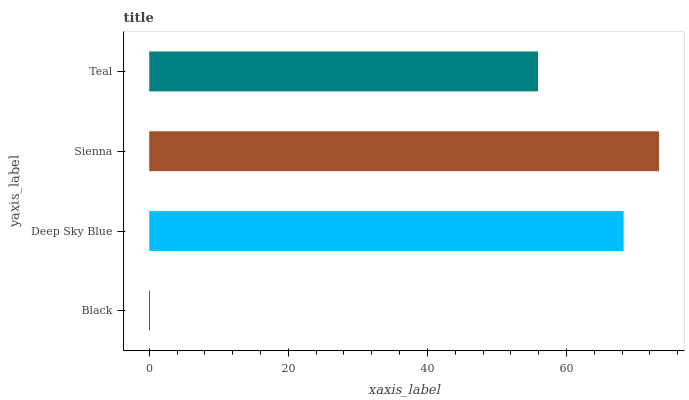Is Black the minimum?
Answer yes or no. Yes. Is Sienna the maximum?
Answer yes or no. Yes. Is Deep Sky Blue the minimum?
Answer yes or no. No. Is Deep Sky Blue the maximum?
Answer yes or no. No. Is Deep Sky Blue greater than Black?
Answer yes or no. Yes. Is Black less than Deep Sky Blue?
Answer yes or no. Yes. Is Black greater than Deep Sky Blue?
Answer yes or no. No. Is Deep Sky Blue less than Black?
Answer yes or no. No. Is Deep Sky Blue the high median?
Answer yes or no. Yes. Is Teal the low median?
Answer yes or no. Yes. Is Black the high median?
Answer yes or no. No. Is Black the low median?
Answer yes or no. No. 